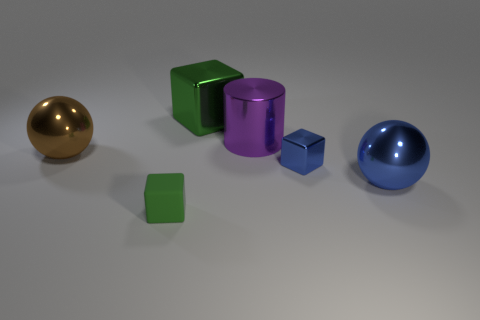Subtract all yellow cylinders. How many green blocks are left? 2 Add 1 rubber blocks. How many objects exist? 7 Subtract all shiny blocks. How many blocks are left? 1 Add 4 big blue metallic things. How many big blue metallic things exist? 5 Subtract 0 cyan cylinders. How many objects are left? 6 Subtract all spheres. How many objects are left? 4 Subtract all large blue spheres. Subtract all blue metallic objects. How many objects are left? 3 Add 6 small blue metallic things. How many small blue metallic things are left? 7 